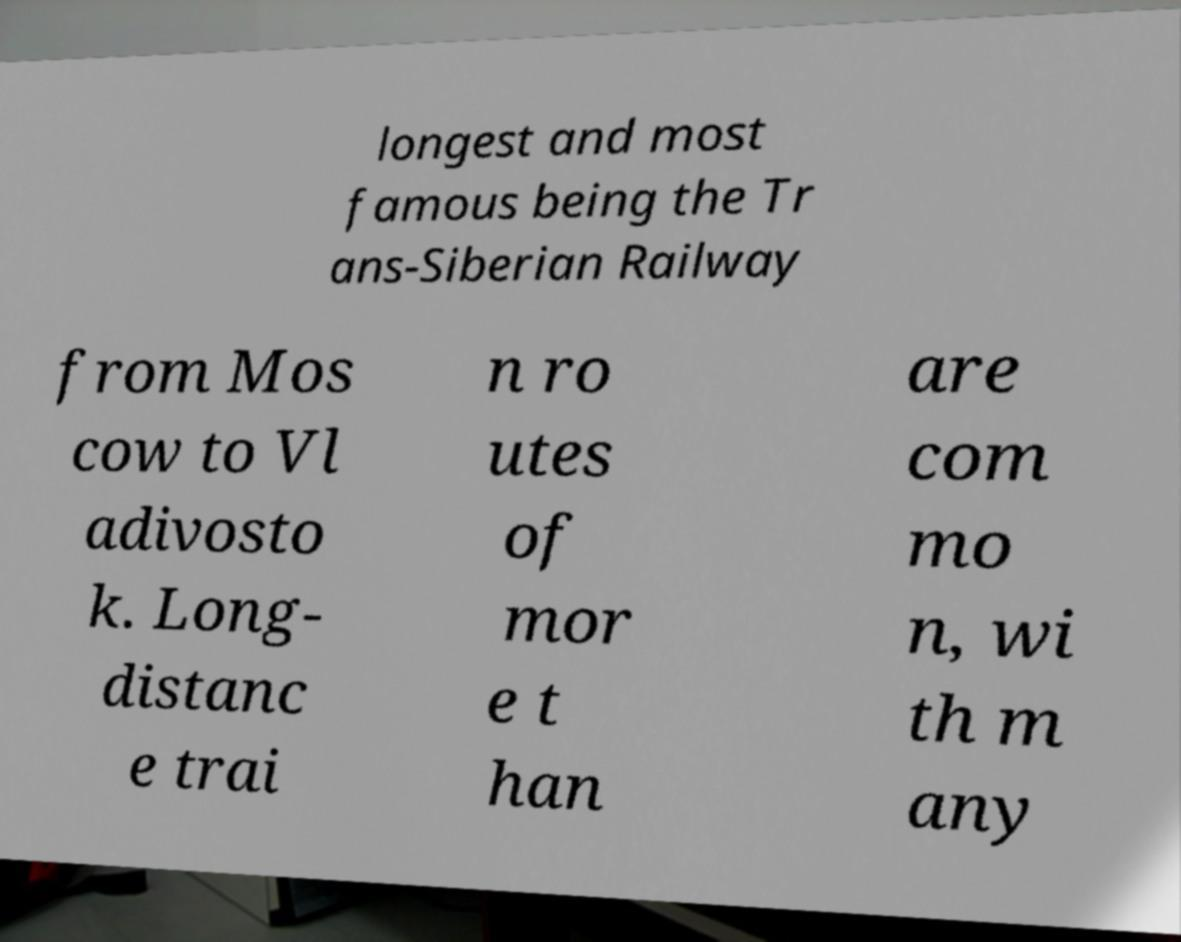I need the written content from this picture converted into text. Can you do that? longest and most famous being the Tr ans-Siberian Railway from Mos cow to Vl adivosto k. Long- distanc e trai n ro utes of mor e t han are com mo n, wi th m any 